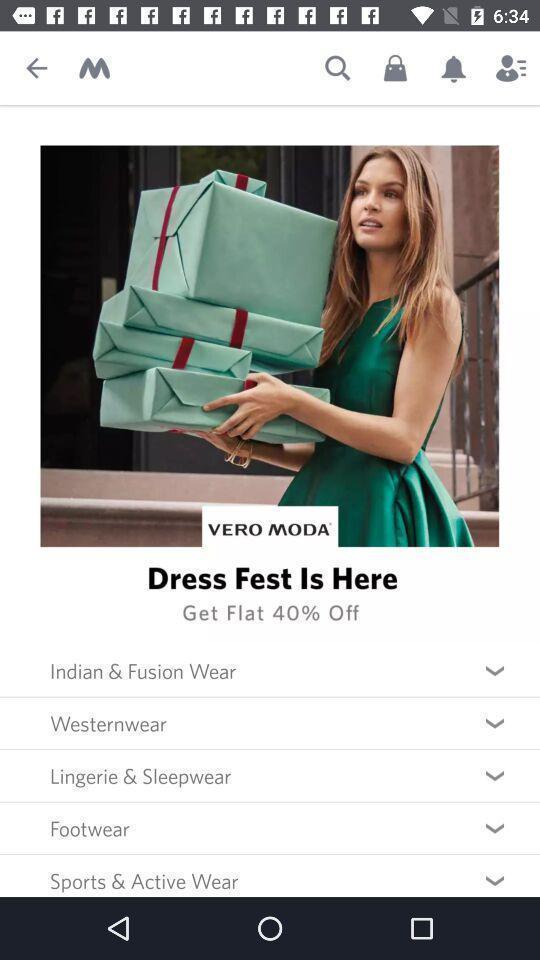Provide a description of this screenshot. Screen shows multiple options in a shopping application. 